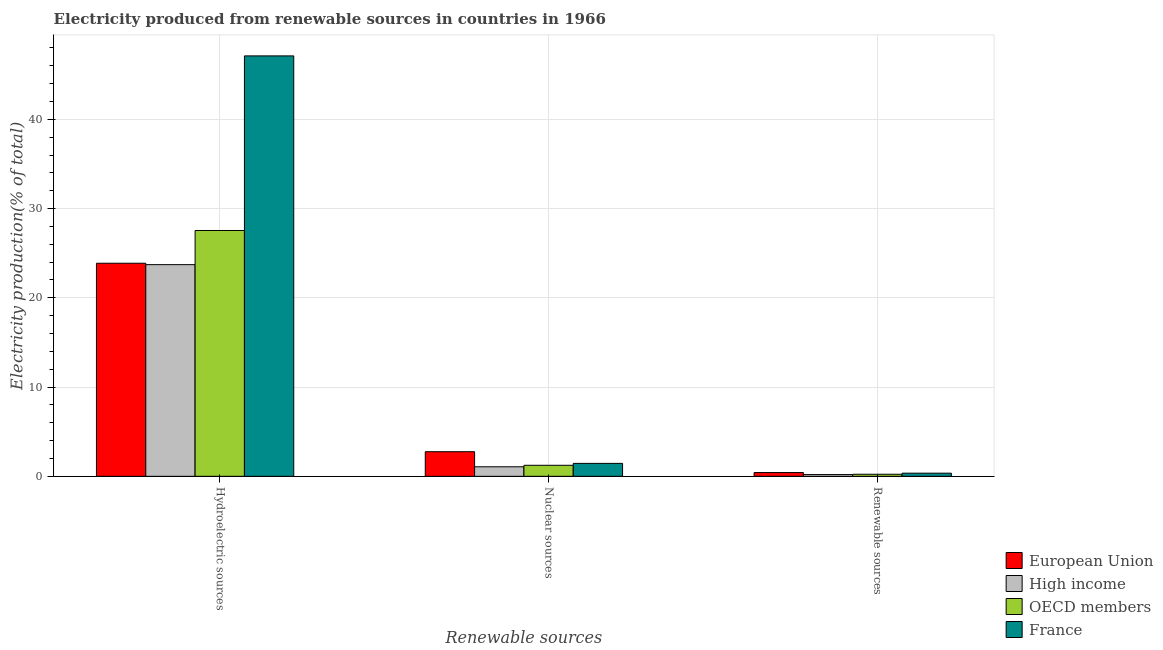How many different coloured bars are there?
Provide a short and direct response. 4. How many groups of bars are there?
Offer a very short reply. 3. Are the number of bars per tick equal to the number of legend labels?
Make the answer very short. Yes. Are the number of bars on each tick of the X-axis equal?
Make the answer very short. Yes. How many bars are there on the 3rd tick from the left?
Offer a terse response. 4. How many bars are there on the 2nd tick from the right?
Provide a succinct answer. 4. What is the label of the 1st group of bars from the left?
Give a very brief answer. Hydroelectric sources. What is the percentage of electricity produced by nuclear sources in France?
Your answer should be very brief. 1.45. Across all countries, what is the maximum percentage of electricity produced by hydroelectric sources?
Make the answer very short. 47.1. Across all countries, what is the minimum percentage of electricity produced by renewable sources?
Ensure brevity in your answer.  0.2. In which country was the percentage of electricity produced by hydroelectric sources maximum?
Make the answer very short. France. In which country was the percentage of electricity produced by renewable sources minimum?
Offer a very short reply. High income. What is the total percentage of electricity produced by renewable sources in the graph?
Keep it short and to the point. 1.2. What is the difference between the percentage of electricity produced by nuclear sources in European Union and that in OECD members?
Ensure brevity in your answer.  1.52. What is the difference between the percentage of electricity produced by renewable sources in High income and the percentage of electricity produced by nuclear sources in OECD members?
Give a very brief answer. -1.04. What is the average percentage of electricity produced by nuclear sources per country?
Give a very brief answer. 1.63. What is the difference between the percentage of electricity produced by nuclear sources and percentage of electricity produced by hydroelectric sources in European Union?
Give a very brief answer. -21.12. In how many countries, is the percentage of electricity produced by nuclear sources greater than 28 %?
Provide a short and direct response. 0. What is the ratio of the percentage of electricity produced by hydroelectric sources in High income to that in European Union?
Your answer should be very brief. 0.99. Is the percentage of electricity produced by hydroelectric sources in High income less than that in France?
Provide a short and direct response. Yes. What is the difference between the highest and the second highest percentage of electricity produced by nuclear sources?
Provide a short and direct response. 1.31. What is the difference between the highest and the lowest percentage of electricity produced by renewable sources?
Your answer should be compact. 0.23. In how many countries, is the percentage of electricity produced by nuclear sources greater than the average percentage of electricity produced by nuclear sources taken over all countries?
Make the answer very short. 1. Is the sum of the percentage of electricity produced by renewable sources in OECD members and High income greater than the maximum percentage of electricity produced by hydroelectric sources across all countries?
Keep it short and to the point. No. What does the 1st bar from the left in Hydroelectric sources represents?
Provide a short and direct response. European Union. What does the 1st bar from the right in Hydroelectric sources represents?
Provide a succinct answer. France. Is it the case that in every country, the sum of the percentage of electricity produced by hydroelectric sources and percentage of electricity produced by nuclear sources is greater than the percentage of electricity produced by renewable sources?
Provide a succinct answer. Yes. How many bars are there?
Your response must be concise. 12. Are all the bars in the graph horizontal?
Your answer should be compact. No. How many countries are there in the graph?
Make the answer very short. 4. Are the values on the major ticks of Y-axis written in scientific E-notation?
Your answer should be very brief. No. Does the graph contain any zero values?
Ensure brevity in your answer.  No. What is the title of the graph?
Offer a terse response. Electricity produced from renewable sources in countries in 1966. What is the label or title of the X-axis?
Provide a succinct answer. Renewable sources. What is the Electricity production(% of total) in European Union in Hydroelectric sources?
Your response must be concise. 23.87. What is the Electricity production(% of total) in High income in Hydroelectric sources?
Provide a short and direct response. 23.72. What is the Electricity production(% of total) in OECD members in Hydroelectric sources?
Make the answer very short. 27.54. What is the Electricity production(% of total) in France in Hydroelectric sources?
Make the answer very short. 47.1. What is the Electricity production(% of total) of European Union in Nuclear sources?
Provide a succinct answer. 2.76. What is the Electricity production(% of total) in High income in Nuclear sources?
Your response must be concise. 1.07. What is the Electricity production(% of total) in OECD members in Nuclear sources?
Provide a succinct answer. 1.24. What is the Electricity production(% of total) of France in Nuclear sources?
Make the answer very short. 1.45. What is the Electricity production(% of total) of European Union in Renewable sources?
Ensure brevity in your answer.  0.42. What is the Electricity production(% of total) in High income in Renewable sources?
Ensure brevity in your answer.  0.2. What is the Electricity production(% of total) of OECD members in Renewable sources?
Your response must be concise. 0.23. What is the Electricity production(% of total) in France in Renewable sources?
Your answer should be compact. 0.35. Across all Renewable sources, what is the maximum Electricity production(% of total) in European Union?
Your response must be concise. 23.87. Across all Renewable sources, what is the maximum Electricity production(% of total) in High income?
Provide a succinct answer. 23.72. Across all Renewable sources, what is the maximum Electricity production(% of total) of OECD members?
Offer a terse response. 27.54. Across all Renewable sources, what is the maximum Electricity production(% of total) of France?
Keep it short and to the point. 47.1. Across all Renewable sources, what is the minimum Electricity production(% of total) in European Union?
Give a very brief answer. 0.42. Across all Renewable sources, what is the minimum Electricity production(% of total) in High income?
Make the answer very short. 0.2. Across all Renewable sources, what is the minimum Electricity production(% of total) of OECD members?
Your response must be concise. 0.23. Across all Renewable sources, what is the minimum Electricity production(% of total) in France?
Ensure brevity in your answer.  0.35. What is the total Electricity production(% of total) in European Union in the graph?
Give a very brief answer. 27.05. What is the total Electricity production(% of total) of High income in the graph?
Offer a very short reply. 24.98. What is the total Electricity production(% of total) in OECD members in the graph?
Your answer should be very brief. 29.01. What is the total Electricity production(% of total) of France in the graph?
Ensure brevity in your answer.  48.9. What is the difference between the Electricity production(% of total) of European Union in Hydroelectric sources and that in Nuclear sources?
Offer a terse response. 21.12. What is the difference between the Electricity production(% of total) of High income in Hydroelectric sources and that in Nuclear sources?
Make the answer very short. 22.65. What is the difference between the Electricity production(% of total) of OECD members in Hydroelectric sources and that in Nuclear sources?
Your answer should be very brief. 26.31. What is the difference between the Electricity production(% of total) of France in Hydroelectric sources and that in Nuclear sources?
Your response must be concise. 45.65. What is the difference between the Electricity production(% of total) in European Union in Hydroelectric sources and that in Renewable sources?
Offer a terse response. 23.45. What is the difference between the Electricity production(% of total) of High income in Hydroelectric sources and that in Renewable sources?
Provide a short and direct response. 23.52. What is the difference between the Electricity production(% of total) of OECD members in Hydroelectric sources and that in Renewable sources?
Provide a succinct answer. 27.31. What is the difference between the Electricity production(% of total) in France in Hydroelectric sources and that in Renewable sources?
Make the answer very short. 46.75. What is the difference between the Electricity production(% of total) of European Union in Nuclear sources and that in Renewable sources?
Keep it short and to the point. 2.33. What is the difference between the Electricity production(% of total) of High income in Nuclear sources and that in Renewable sources?
Your answer should be very brief. 0.87. What is the difference between the Electricity production(% of total) in France in Nuclear sources and that in Renewable sources?
Your response must be concise. 1.1. What is the difference between the Electricity production(% of total) of European Union in Hydroelectric sources and the Electricity production(% of total) of High income in Nuclear sources?
Your answer should be compact. 22.8. What is the difference between the Electricity production(% of total) in European Union in Hydroelectric sources and the Electricity production(% of total) in OECD members in Nuclear sources?
Your answer should be very brief. 22.64. What is the difference between the Electricity production(% of total) in European Union in Hydroelectric sources and the Electricity production(% of total) in France in Nuclear sources?
Keep it short and to the point. 22.42. What is the difference between the Electricity production(% of total) in High income in Hydroelectric sources and the Electricity production(% of total) in OECD members in Nuclear sources?
Make the answer very short. 22.48. What is the difference between the Electricity production(% of total) in High income in Hydroelectric sources and the Electricity production(% of total) in France in Nuclear sources?
Keep it short and to the point. 22.27. What is the difference between the Electricity production(% of total) of OECD members in Hydroelectric sources and the Electricity production(% of total) of France in Nuclear sources?
Your answer should be very brief. 26.09. What is the difference between the Electricity production(% of total) in European Union in Hydroelectric sources and the Electricity production(% of total) in High income in Renewable sources?
Ensure brevity in your answer.  23.68. What is the difference between the Electricity production(% of total) of European Union in Hydroelectric sources and the Electricity production(% of total) of OECD members in Renewable sources?
Give a very brief answer. 23.64. What is the difference between the Electricity production(% of total) in European Union in Hydroelectric sources and the Electricity production(% of total) in France in Renewable sources?
Ensure brevity in your answer.  23.52. What is the difference between the Electricity production(% of total) of High income in Hydroelectric sources and the Electricity production(% of total) of OECD members in Renewable sources?
Offer a very short reply. 23.48. What is the difference between the Electricity production(% of total) in High income in Hydroelectric sources and the Electricity production(% of total) in France in Renewable sources?
Make the answer very short. 23.36. What is the difference between the Electricity production(% of total) in OECD members in Hydroelectric sources and the Electricity production(% of total) in France in Renewable sources?
Offer a very short reply. 27.19. What is the difference between the Electricity production(% of total) of European Union in Nuclear sources and the Electricity production(% of total) of High income in Renewable sources?
Your answer should be compact. 2.56. What is the difference between the Electricity production(% of total) of European Union in Nuclear sources and the Electricity production(% of total) of OECD members in Renewable sources?
Offer a terse response. 2.52. What is the difference between the Electricity production(% of total) in European Union in Nuclear sources and the Electricity production(% of total) in France in Renewable sources?
Your answer should be very brief. 2.4. What is the difference between the Electricity production(% of total) of High income in Nuclear sources and the Electricity production(% of total) of OECD members in Renewable sources?
Provide a short and direct response. 0.84. What is the difference between the Electricity production(% of total) of High income in Nuclear sources and the Electricity production(% of total) of France in Renewable sources?
Offer a terse response. 0.72. What is the difference between the Electricity production(% of total) in OECD members in Nuclear sources and the Electricity production(% of total) in France in Renewable sources?
Keep it short and to the point. 0.88. What is the average Electricity production(% of total) in European Union per Renewable sources?
Your response must be concise. 9.02. What is the average Electricity production(% of total) in High income per Renewable sources?
Provide a succinct answer. 8.33. What is the average Electricity production(% of total) in OECD members per Renewable sources?
Provide a short and direct response. 9.67. What is the average Electricity production(% of total) in France per Renewable sources?
Your answer should be very brief. 16.3. What is the difference between the Electricity production(% of total) in European Union and Electricity production(% of total) in High income in Hydroelectric sources?
Your answer should be compact. 0.16. What is the difference between the Electricity production(% of total) in European Union and Electricity production(% of total) in OECD members in Hydroelectric sources?
Provide a short and direct response. -3.67. What is the difference between the Electricity production(% of total) in European Union and Electricity production(% of total) in France in Hydroelectric sources?
Keep it short and to the point. -23.23. What is the difference between the Electricity production(% of total) in High income and Electricity production(% of total) in OECD members in Hydroelectric sources?
Ensure brevity in your answer.  -3.83. What is the difference between the Electricity production(% of total) in High income and Electricity production(% of total) in France in Hydroelectric sources?
Your answer should be very brief. -23.39. What is the difference between the Electricity production(% of total) in OECD members and Electricity production(% of total) in France in Hydroelectric sources?
Give a very brief answer. -19.56. What is the difference between the Electricity production(% of total) in European Union and Electricity production(% of total) in High income in Nuclear sources?
Give a very brief answer. 1.69. What is the difference between the Electricity production(% of total) of European Union and Electricity production(% of total) of OECD members in Nuclear sources?
Offer a terse response. 1.52. What is the difference between the Electricity production(% of total) of European Union and Electricity production(% of total) of France in Nuclear sources?
Offer a very short reply. 1.31. What is the difference between the Electricity production(% of total) in High income and Electricity production(% of total) in OECD members in Nuclear sources?
Offer a very short reply. -0.17. What is the difference between the Electricity production(% of total) of High income and Electricity production(% of total) of France in Nuclear sources?
Provide a short and direct response. -0.38. What is the difference between the Electricity production(% of total) in OECD members and Electricity production(% of total) in France in Nuclear sources?
Your answer should be compact. -0.21. What is the difference between the Electricity production(% of total) of European Union and Electricity production(% of total) of High income in Renewable sources?
Offer a terse response. 0.23. What is the difference between the Electricity production(% of total) in European Union and Electricity production(% of total) in OECD members in Renewable sources?
Your answer should be very brief. 0.19. What is the difference between the Electricity production(% of total) in European Union and Electricity production(% of total) in France in Renewable sources?
Offer a terse response. 0.07. What is the difference between the Electricity production(% of total) of High income and Electricity production(% of total) of OECD members in Renewable sources?
Provide a short and direct response. -0.04. What is the difference between the Electricity production(% of total) of High income and Electricity production(% of total) of France in Renewable sources?
Your response must be concise. -0.16. What is the difference between the Electricity production(% of total) of OECD members and Electricity production(% of total) of France in Renewable sources?
Ensure brevity in your answer.  -0.12. What is the ratio of the Electricity production(% of total) of European Union in Hydroelectric sources to that in Nuclear sources?
Provide a short and direct response. 8.66. What is the ratio of the Electricity production(% of total) in High income in Hydroelectric sources to that in Nuclear sources?
Offer a very short reply. 22.22. What is the ratio of the Electricity production(% of total) in OECD members in Hydroelectric sources to that in Nuclear sources?
Offer a terse response. 22.29. What is the ratio of the Electricity production(% of total) in France in Hydroelectric sources to that in Nuclear sources?
Your answer should be very brief. 32.5. What is the ratio of the Electricity production(% of total) in European Union in Hydroelectric sources to that in Renewable sources?
Offer a terse response. 56.59. What is the ratio of the Electricity production(% of total) of High income in Hydroelectric sources to that in Renewable sources?
Make the answer very short. 120.9. What is the ratio of the Electricity production(% of total) in OECD members in Hydroelectric sources to that in Renewable sources?
Ensure brevity in your answer.  118.88. What is the ratio of the Electricity production(% of total) of France in Hydroelectric sources to that in Renewable sources?
Make the answer very short. 133.84. What is the ratio of the Electricity production(% of total) in European Union in Nuclear sources to that in Renewable sources?
Offer a terse response. 6.53. What is the ratio of the Electricity production(% of total) in High income in Nuclear sources to that in Renewable sources?
Ensure brevity in your answer.  5.44. What is the ratio of the Electricity production(% of total) in OECD members in Nuclear sources to that in Renewable sources?
Offer a terse response. 5.33. What is the ratio of the Electricity production(% of total) in France in Nuclear sources to that in Renewable sources?
Provide a short and direct response. 4.12. What is the difference between the highest and the second highest Electricity production(% of total) of European Union?
Ensure brevity in your answer.  21.12. What is the difference between the highest and the second highest Electricity production(% of total) in High income?
Give a very brief answer. 22.65. What is the difference between the highest and the second highest Electricity production(% of total) in OECD members?
Your answer should be compact. 26.31. What is the difference between the highest and the second highest Electricity production(% of total) in France?
Give a very brief answer. 45.65. What is the difference between the highest and the lowest Electricity production(% of total) of European Union?
Your answer should be very brief. 23.45. What is the difference between the highest and the lowest Electricity production(% of total) of High income?
Offer a terse response. 23.52. What is the difference between the highest and the lowest Electricity production(% of total) in OECD members?
Offer a terse response. 27.31. What is the difference between the highest and the lowest Electricity production(% of total) of France?
Your answer should be very brief. 46.75. 